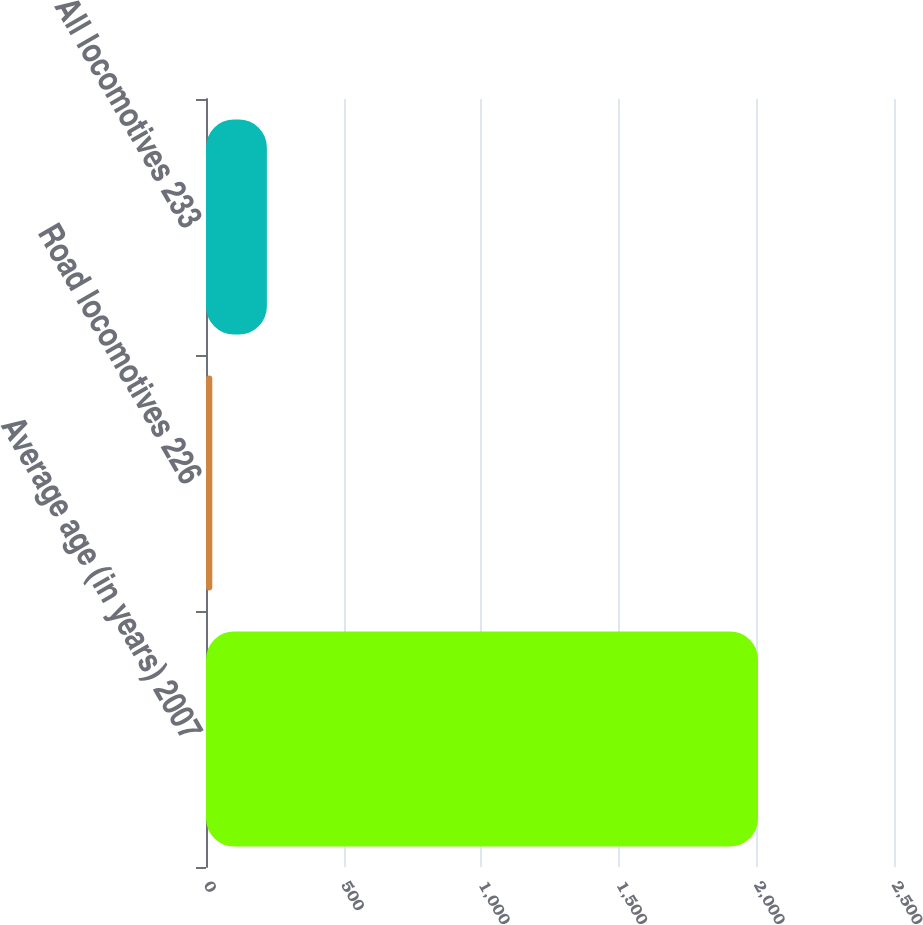Convert chart. <chart><loc_0><loc_0><loc_500><loc_500><bar_chart><fcel>Average age (in years) 2007<fcel>Road locomotives 226<fcel>All locomotives 233<nl><fcel>2006<fcel>22.9<fcel>221.21<nl></chart> 